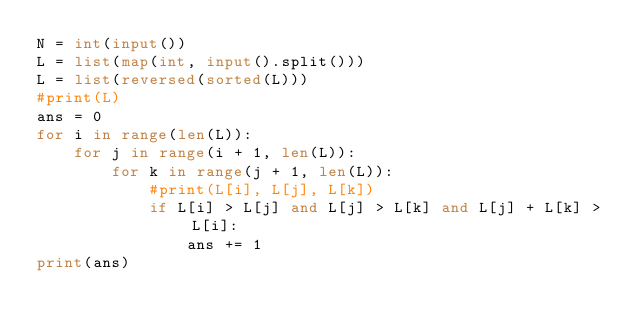Convert code to text. <code><loc_0><loc_0><loc_500><loc_500><_Python_>N = int(input())
L = list(map(int, input().split()))
L = list(reversed(sorted(L)))
#print(L)
ans = 0
for i in range(len(L)):
    for j in range(i + 1, len(L)):
        for k in range(j + 1, len(L)):
            #print(L[i], L[j], L[k])
            if L[i] > L[j] and L[j] > L[k] and L[j] + L[k] > L[i]:
                ans += 1
print(ans)</code> 